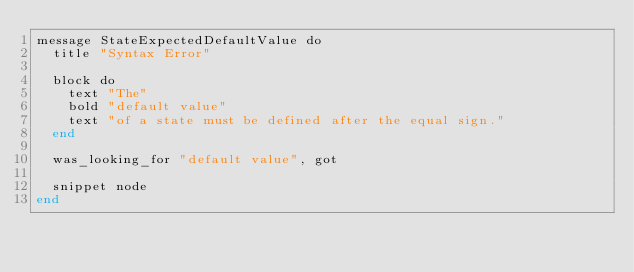Convert code to text. <code><loc_0><loc_0><loc_500><loc_500><_Crystal_>message StateExpectedDefaultValue do
  title "Syntax Error"

  block do
    text "The"
    bold "default value"
    text "of a state must be defined after the equal sign."
  end

  was_looking_for "default value", got

  snippet node
end
</code> 